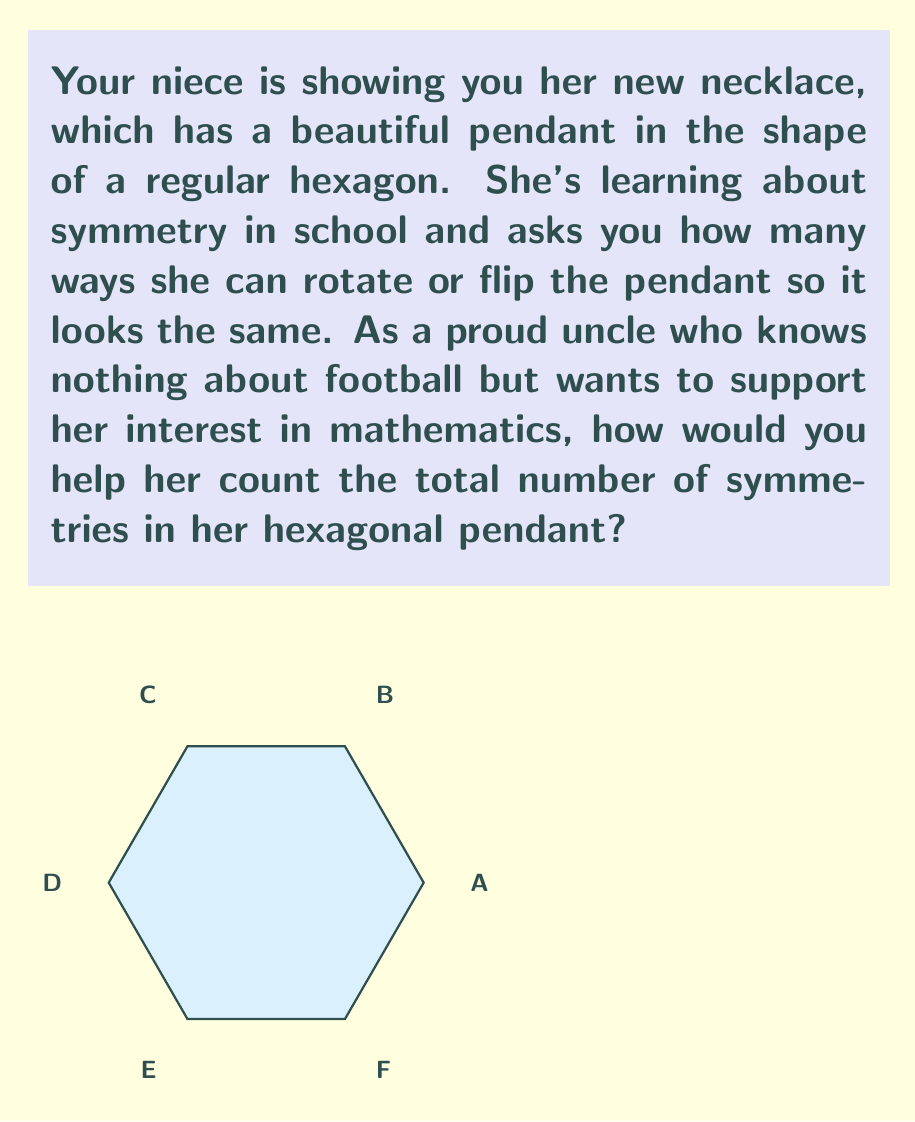Teach me how to tackle this problem. Let's approach this step-by-step:

1) Rotational symmetries:
   - A regular hexagon can be rotated by multiples of 60° (or $\frac{\pi}{3}$ radians) to look the same.
   - There are 6 rotational symmetries: 0°, 60°, 120°, 180°, 240°, 300°.

2) Reflection symmetries:
   - A hexagon has 6 lines of reflection symmetry:
     a) 3 passing through opposite vertices
     b) 3 passing through the midpoints of opposite sides

3) Total symmetries:
   - The total number of symmetries is the sum of rotational and reflectional symmetries.
   - However, the identity (0° rotation) is counted in both, so we don't double count it.

4) Calculation:
   $$ \text{Total symmetries} = \text{Rotational symmetries} + \text{Reflectional symmetries} $$
   $$ = 6 + 6 = 12 $$

5) Group theory perspective:
   - These symmetries form the dihedral group $D_6$, which has order 12.
   - The order of this group is given by the formula $2n$, where $n$ is the number of sides of the regular polygon.

Therefore, there are 12 ways to rotate or flip the hexagonal pendant so that it looks the same.
Answer: 12 symmetries 